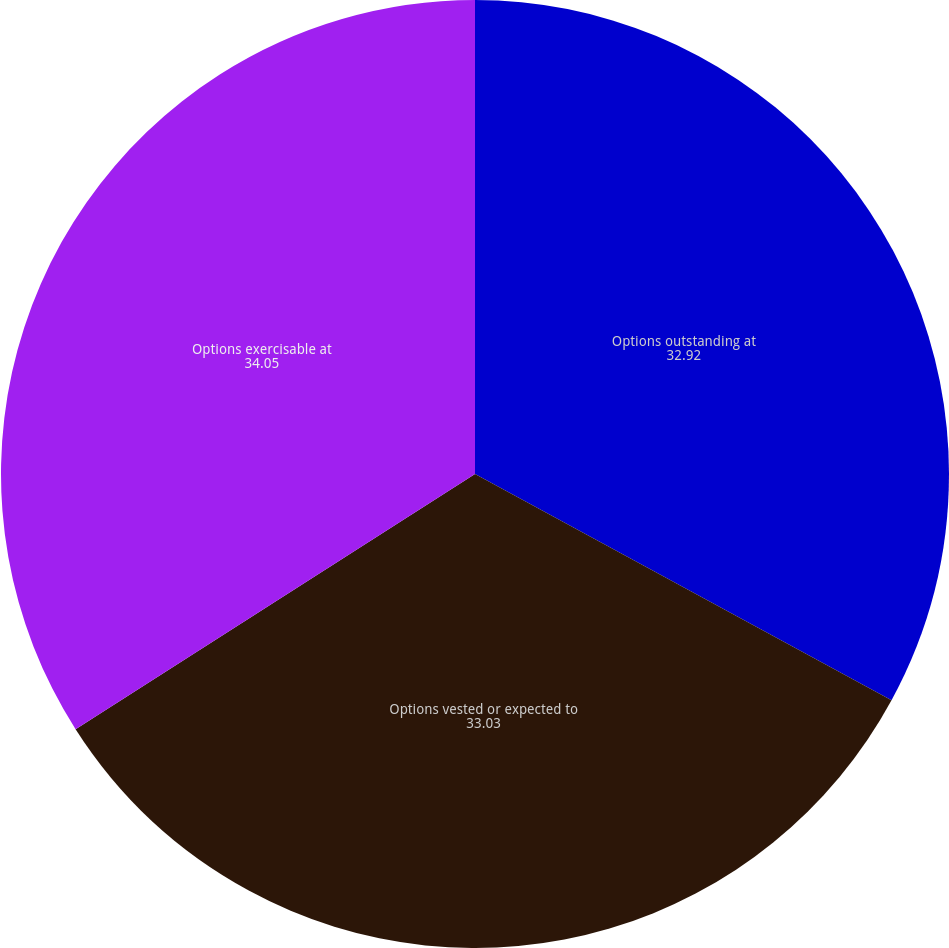Convert chart to OTSL. <chart><loc_0><loc_0><loc_500><loc_500><pie_chart><fcel>Options outstanding at<fcel>Options vested or expected to<fcel>Options exercisable at<nl><fcel>32.92%<fcel>33.03%<fcel>34.05%<nl></chart> 